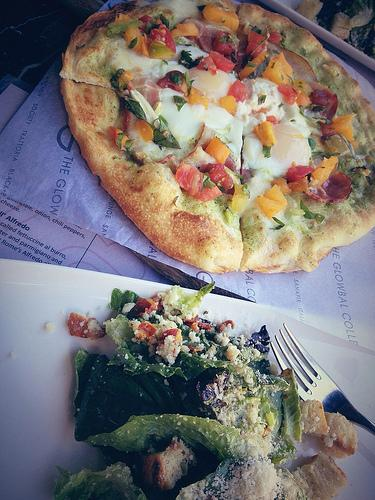What is the composition appearing in the image? The image consists of a freshly sliced pizza with cheese and vegetables, a green salad with croutons and grated cheese, and a metallic fork on a white plate. How many pizza slices are visible in this image? There are four pizza slices. Can you list some of the toppings on this pizza? Bacon, tomato, cheese, green scallions, and yellow pepper. Mention the primary ingredients present in the salad of the image. Green salad, croutons, grated parmesan cheese, and white cheese on a green leaf. Perform a quick sentiment analysis of the image. The image has a positive sentiment, showcasing a delicious meal with fresh pizza and a healthy green salad. What is the main dish visible in the image? Freshly sliced pizza with cheese, bacon, tomato, and vegetables. What kind of accessories or utensils can be seen in the picture? A metallic fork resting on the edge of the green salad plate. Estimate the number of croutons mixed with the green salad in the image. There are three crispy croutons with cheese on them. What is placed under the pizza to prevent it from sticking to the straw plate? A layer of food grade tissue liner or wrapping paper. Write a brief description of the image content. The image features a sliced vegetarian pizza alongside a plate of green salad mixed with croutons, grated cheese, and garnishes. 